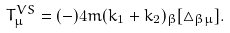Convert formula to latex. <formula><loc_0><loc_0><loc_500><loc_500>T _ { \mu } ^ { V S } = ( - ) 4 m ( k _ { 1 } + k _ { 2 } ) _ { \beta } [ \triangle _ { \beta \mu } ] .</formula> 